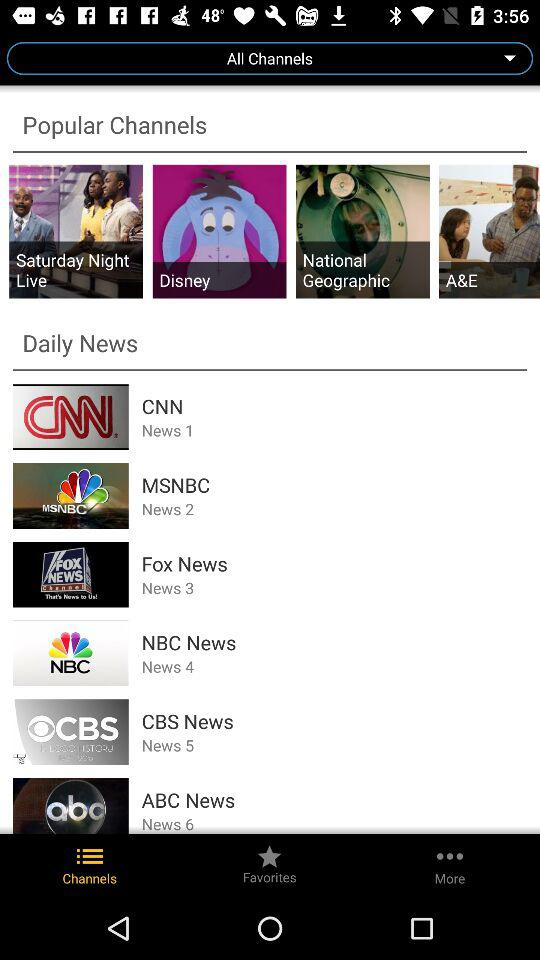How many items are in the Daily News section?
Answer the question using a single word or phrase. 6 